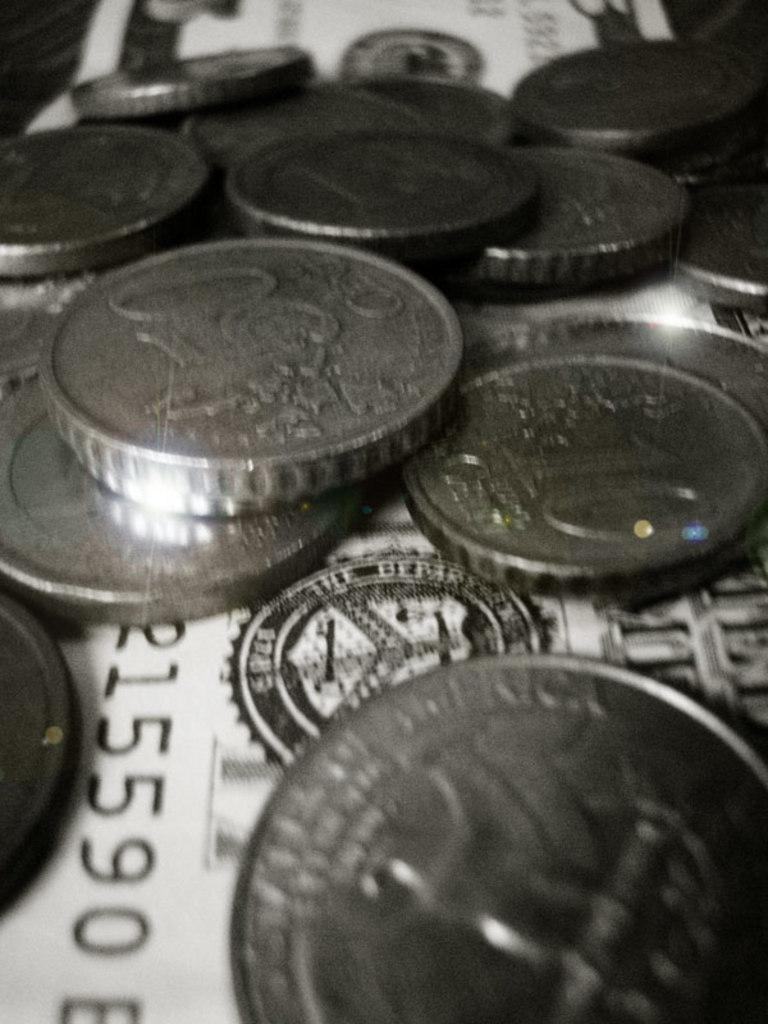What type of currency can be seen in the image? There are coins and dollar bills present in the image. How does the digestion process work for the coins in the image? The image does not show any digestion process, as it only features coins and dollar bills. What type of women can be seen in the image? There are no women present in the image; it only features coins and dollar bills. 